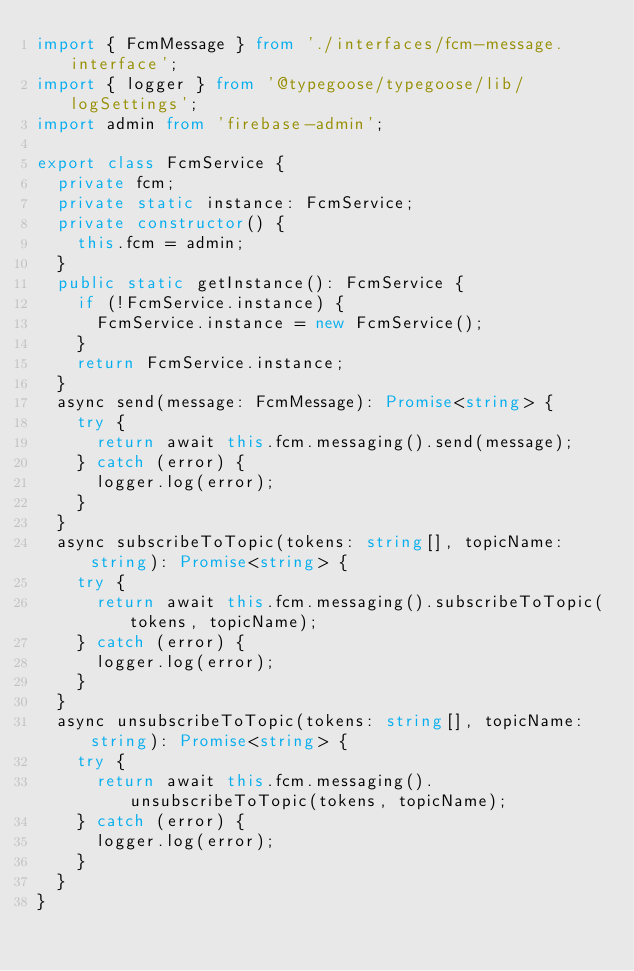Convert code to text. <code><loc_0><loc_0><loc_500><loc_500><_TypeScript_>import { FcmMessage } from './interfaces/fcm-message.interface';
import { logger } from '@typegoose/typegoose/lib/logSettings';
import admin from 'firebase-admin';

export class FcmService {
  private fcm;
  private static instance: FcmService;
  private constructor() {
    this.fcm = admin;
  }
  public static getInstance(): FcmService {
    if (!FcmService.instance) {
      FcmService.instance = new FcmService();
    }
    return FcmService.instance;
  }
  async send(message: FcmMessage): Promise<string> {
    try {
      return await this.fcm.messaging().send(message);
    } catch (error) {
      logger.log(error);
    }
  }
  async subscribeToTopic(tokens: string[], topicName: string): Promise<string> {
    try {
      return await this.fcm.messaging().subscribeToTopic(tokens, topicName);
    } catch (error) {
      logger.log(error);
    }
  }
  async unsubscribeToTopic(tokens: string[], topicName: string): Promise<string> {
    try {
      return await this.fcm.messaging().unsubscribeToTopic(tokens, topicName);
    } catch (error) {
      logger.log(error);
    }
  }
}
</code> 